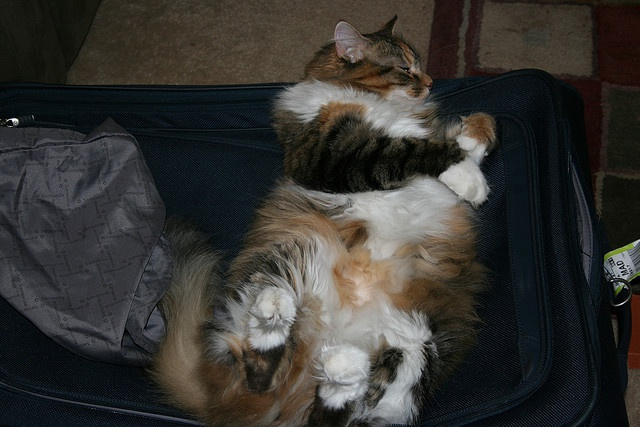Describe the objects in this image and their specific colors. I can see cat in black, darkgray, and gray tones and suitcase in black and gray tones in this image. 